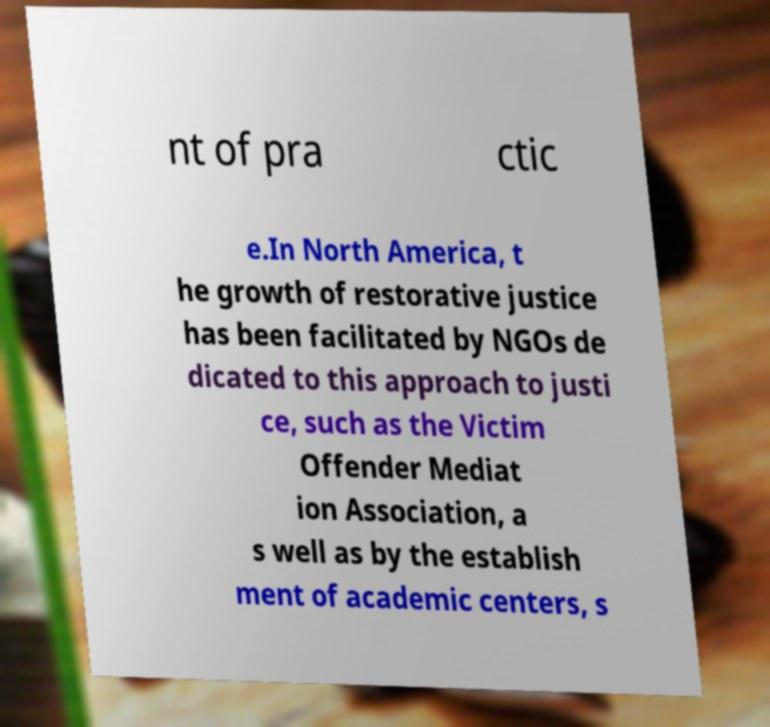Could you assist in decoding the text presented in this image and type it out clearly? nt of pra ctic e.In North America, t he growth of restorative justice has been facilitated by NGOs de dicated to this approach to justi ce, such as the Victim Offender Mediat ion Association, a s well as by the establish ment of academic centers, s 